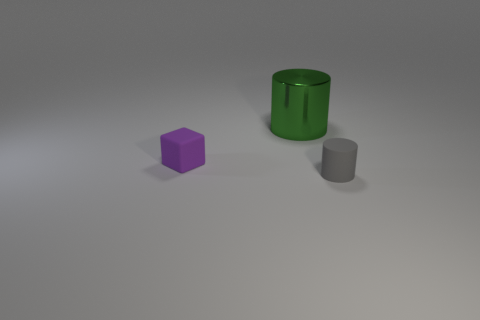There is a tiny matte thing that is behind the rubber cylinder; how many matte things are to the right of it?
Provide a succinct answer. 1. How many other objects are the same material as the purple thing?
Your answer should be compact. 1. Is the thing right of the green metallic cylinder made of the same material as the small object left of the metallic cylinder?
Make the answer very short. Yes. Are there any other things that have the same shape as the green object?
Your answer should be compact. Yes. Does the gray cylinder have the same material as the cylinder behind the tiny matte cube?
Your answer should be compact. No. What is the color of the thing that is behind the tiny thing that is behind the thing that is in front of the purple matte thing?
Ensure brevity in your answer.  Green. There is a gray matte thing that is the same size as the purple block; what is its shape?
Provide a short and direct response. Cylinder. Is there anything else that is the same size as the cube?
Provide a succinct answer. Yes. There is a thing that is left of the large object; is it the same size as the cylinder that is in front of the cube?
Your answer should be very brief. Yes. What size is the cylinder that is behind the gray rubber cylinder?
Provide a succinct answer. Large. 